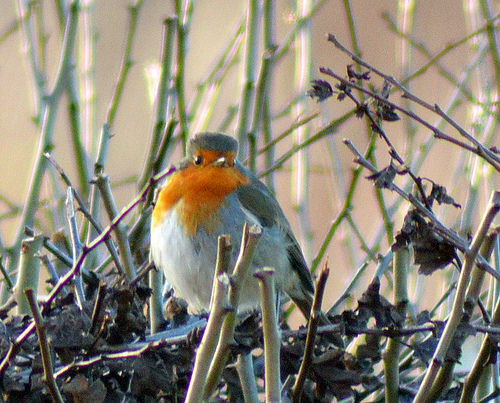<image>
Can you confirm if the robin is on the twig? Yes. Looking at the image, I can see the robin is positioned on top of the twig, with the twig providing support. Where is the bird in relation to the stick? Is it above the stick? Yes. The bird is positioned above the stick in the vertical space, higher up in the scene. 